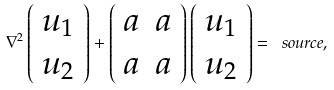<formula> <loc_0><loc_0><loc_500><loc_500>\nabla ^ { 2 } \left ( \begin{array} { c } u _ { 1 } \\ u _ { 2 } \end{array} \right ) + \left ( \begin{array} { c c } a & a \\ a & a \end{array} \right ) \left ( \begin{array} { c } u _ { 1 } \\ u _ { 2 } \end{array} \right ) = \ s o u r c e ,</formula> 